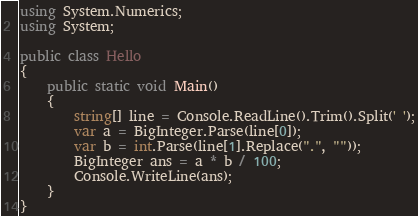<code> <loc_0><loc_0><loc_500><loc_500><_C#_>using System.Numerics;
using System;

public class Hello
{
    public static void Main()
    {
        string[] line = Console.ReadLine().Trim().Split(' ');
        var a = BigInteger.Parse(line[0]);
        var b = int.Parse(line[1].Replace(".", ""));
        BigInteger ans = a * b / 100;
        Console.WriteLine(ans);
    }
}</code> 